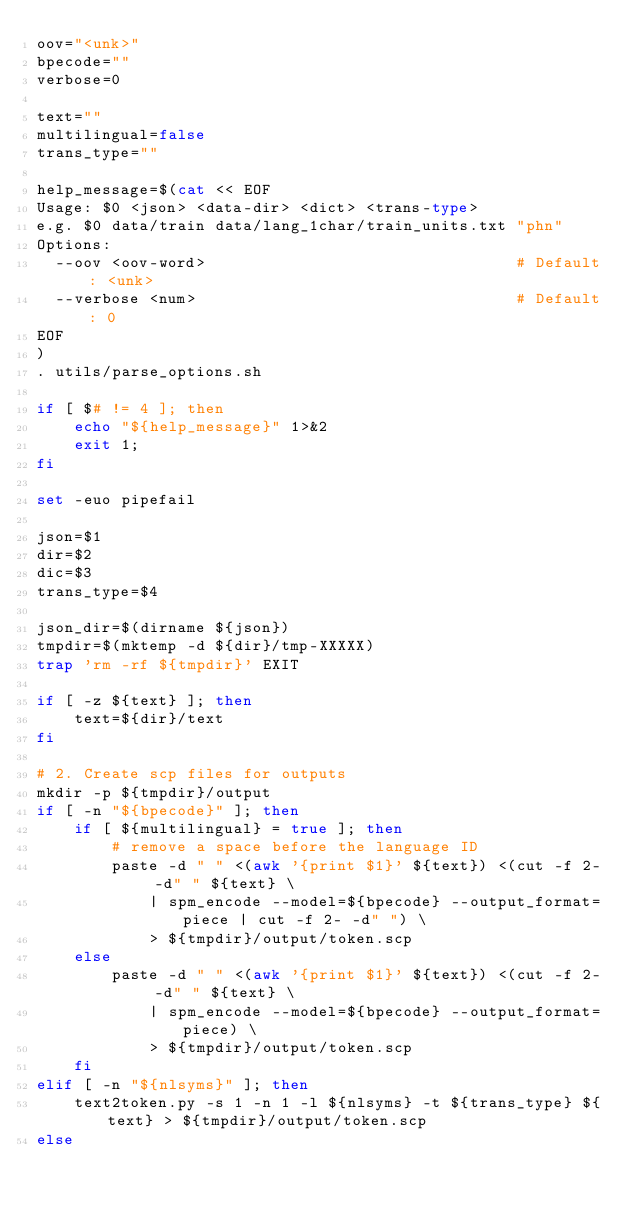Convert code to text. <code><loc_0><loc_0><loc_500><loc_500><_Bash_>oov="<unk>"
bpecode=""
verbose=0

text=""
multilingual=false
trans_type=""

help_message=$(cat << EOF
Usage: $0 <json> <data-dir> <dict> <trans-type>
e.g. $0 data/train data/lang_1char/train_units.txt "phn"
Options:
  --oov <oov-word>                                 # Default: <unk>
  --verbose <num>                                  # Default: 0
EOF
)
. utils/parse_options.sh

if [ $# != 4 ]; then
    echo "${help_message}" 1>&2
    exit 1;
fi

set -euo pipefail

json=$1
dir=$2
dic=$3
trans_type=$4

json_dir=$(dirname ${json})
tmpdir=$(mktemp -d ${dir}/tmp-XXXXX)
trap 'rm -rf ${tmpdir}' EXIT

if [ -z ${text} ]; then
    text=${dir}/text
fi

# 2. Create scp files for outputs
mkdir -p ${tmpdir}/output
if [ -n "${bpecode}" ]; then
    if [ ${multilingual} = true ]; then
        # remove a space before the language ID
        paste -d " " <(awk '{print $1}' ${text}) <(cut -f 2- -d" " ${text} \
            | spm_encode --model=${bpecode} --output_format=piece | cut -f 2- -d" ") \
            > ${tmpdir}/output/token.scp
    else
        paste -d " " <(awk '{print $1}' ${text}) <(cut -f 2- -d" " ${text} \
            | spm_encode --model=${bpecode} --output_format=piece) \
            > ${tmpdir}/output/token.scp
    fi
elif [ -n "${nlsyms}" ]; then
    text2token.py -s 1 -n 1 -l ${nlsyms} -t ${trans_type} ${text} > ${tmpdir}/output/token.scp
else
    </code> 